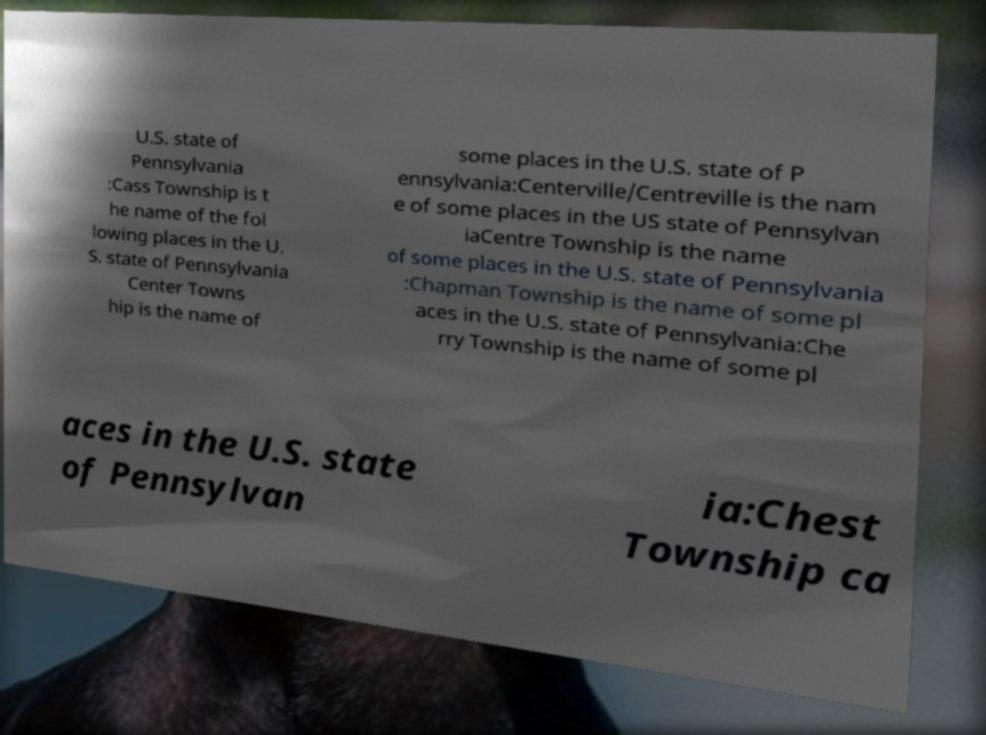There's text embedded in this image that I need extracted. Can you transcribe it verbatim? U.S. state of Pennsylvania :Cass Township is t he name of the fol lowing places in the U. S. state of Pennsylvania Center Towns hip is the name of some places in the U.S. state of P ennsylvania:Centerville/Centreville is the nam e of some places in the US state of Pennsylvan iaCentre Township is the name of some places in the U.S. state of Pennsylvania :Chapman Township is the name of some pl aces in the U.S. state of Pennsylvania:Che rry Township is the name of some pl aces in the U.S. state of Pennsylvan ia:Chest Township ca 